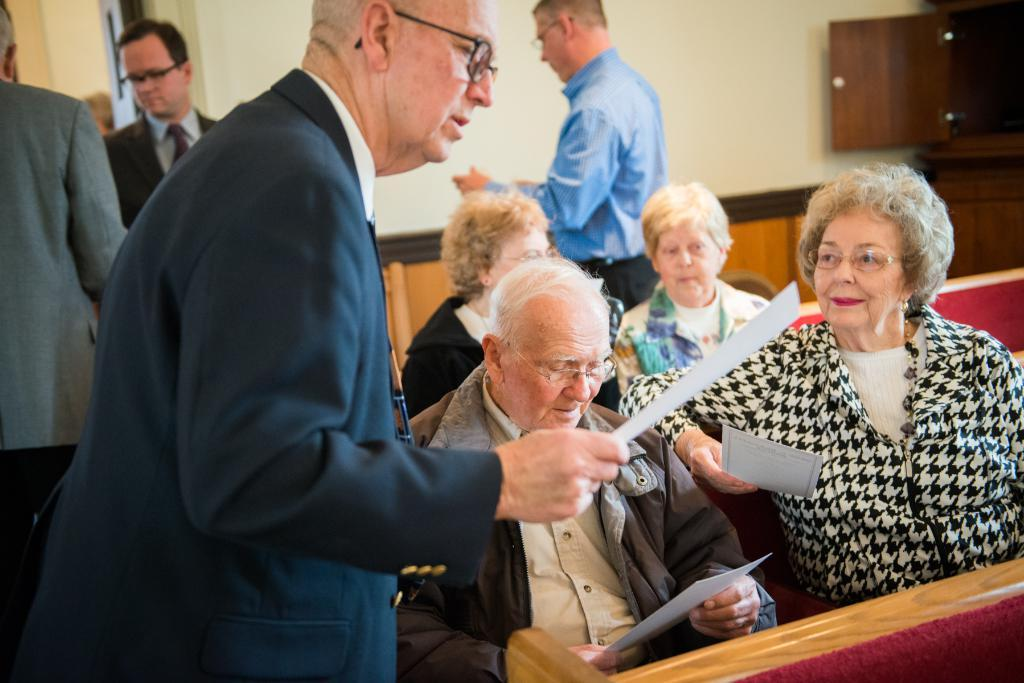What are the people in the image doing? There are people sitting and standing in the image. What are some of the people holding? Three people are holding papers in the image. What type of furniture is present in the image? There are sofas in the image. What can be seen in the background of the image? There is a wall and a cupboard in the background of the image. What color is the orange that the people are using to write on the papers? There is no orange present in the image, and the people are not using it to write on the papers. What type of amusement can be seen in the image? There is no amusement depicted in the image; it primarily features people sitting and standing with papers. 